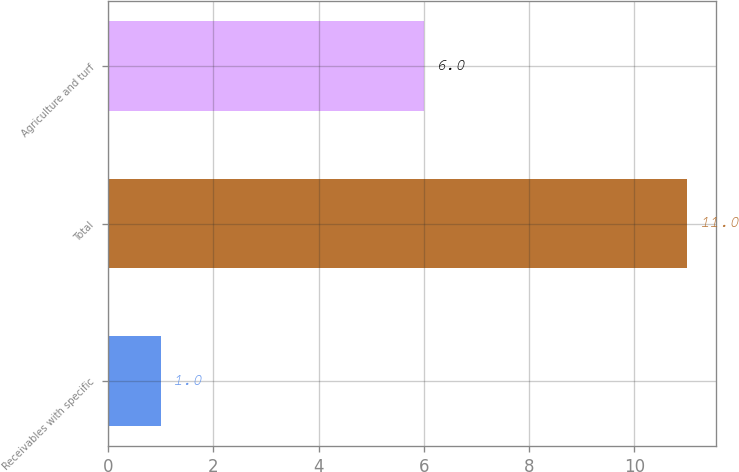<chart> <loc_0><loc_0><loc_500><loc_500><bar_chart><fcel>Receivables with specific<fcel>Total<fcel>Agriculture and turf<nl><fcel>1<fcel>11<fcel>6<nl></chart> 